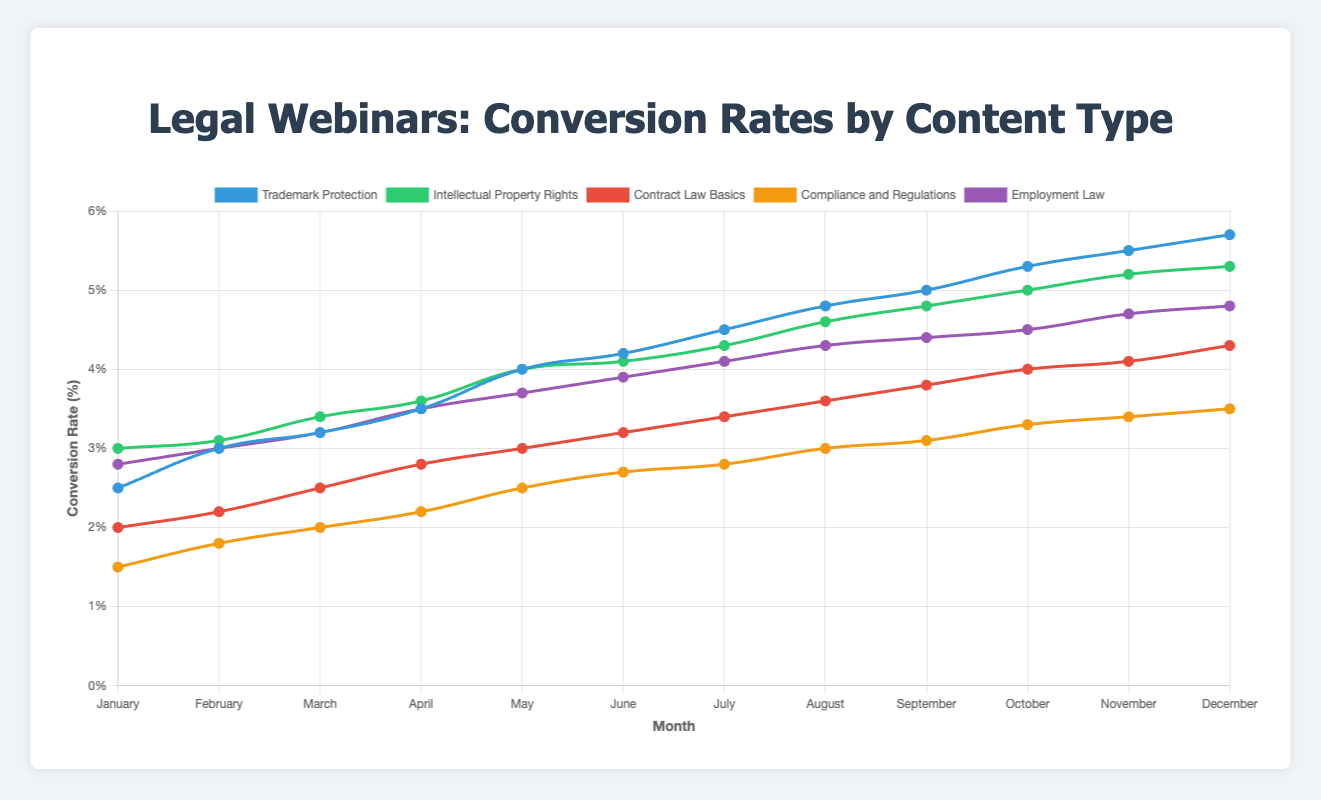Which content type had the highest conversion rate in December? In December, "Trademark Protection" had the highest conversion rate of 5.7%, which is visually observable as the highest peak in the chart.
Answer: Trademark Protection Which content type consistently had the lowest conversion rate throughout the year? Throughout the year, "Compliance and Regulations" had the lowest conversion rate each month, starting from 1.5% in January and reaching 3.5% in December. This is the line closest to the bottom of the chart.
Answer: Compliance and Regulations Which month showed the highest increase in conversion rate for "Trademark Protection"? The highest increase in conversion rate for "Trademark Protection" occurred between November and December, from 5.5% to 5.7%, a 0.2% increase, which is the steepest part of its curve.
Answer: December What is the average conversion rate for "Employment Law" over the entire year? To calculate the average, sum the monthly conversion rates (2.8 + 3.0 + 3.2 + 3.5 + 3.7 + 3.9 + 4.1 + 4.3 + 4.4 + 4.5 + 4.7 + 4.8) and divide by 12: (46.9 / 12) = 3.91%.
Answer: 3.91% Between which two months did "Intellectual Property Rights" see the largest spike in conversion rate? The largest spike in conversion rate for "Intellectual Property Rights" occurred between April (3.6%) and May (4.0%), a 0.4% increase.
Answer: April and May Compare the conversion rates of "Contract Law Basics" and "Compliance and Regulations" in July. Which one is higher, and by how much? In July, "Contract Law Basics" had a conversion rate of 3.4%, and "Compliance and Regulations" had 2.8%. The difference is 3.4 - 2.8 = 0.6%.
Answer: Contract Law Basics by 0.6% Which content type had a more significant upward trend over the year: "Trademark Protection" or "Employment Law"? "Trademark Protection" went from 2.5% in January to 5.7% in December, an increase of 3.2%. "Employment Law" increased from 2.8% to 4.8%, an increase of 2.0%. Therefore, "Trademark Protection" had a more significant upward trend.
Answer: Trademark Protection What is the combined conversion rate for "Intellectual Property Rights" and "Contract Law Basics" in March? Adding the March conversion rates for "Intellectual Property Rights" (3.4%) and "Contract Law Basics" (2.5%) gives 3.4 + 2.5 = 5.9%.
Answer: 5.9% Examine the chart. Did any of the content types' conversion rates decrease in any month from the previous month? None of the lines in the chart show a downward slope, indicating that all content types had conversion rates that either increased or stayed the same each month.
Answer: No 